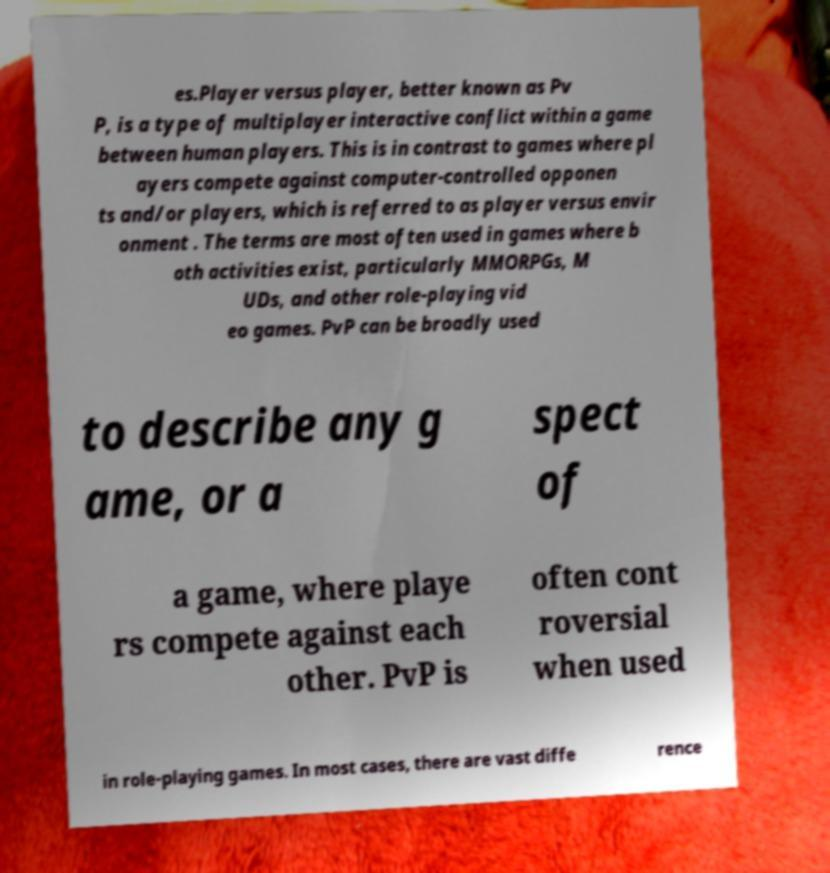What messages or text are displayed in this image? I need them in a readable, typed format. es.Player versus player, better known as Pv P, is a type of multiplayer interactive conflict within a game between human players. This is in contrast to games where pl ayers compete against computer-controlled opponen ts and/or players, which is referred to as player versus envir onment . The terms are most often used in games where b oth activities exist, particularly MMORPGs, M UDs, and other role-playing vid eo games. PvP can be broadly used to describe any g ame, or a spect of a game, where playe rs compete against each other. PvP is often cont roversial when used in role-playing games. In most cases, there are vast diffe rence 